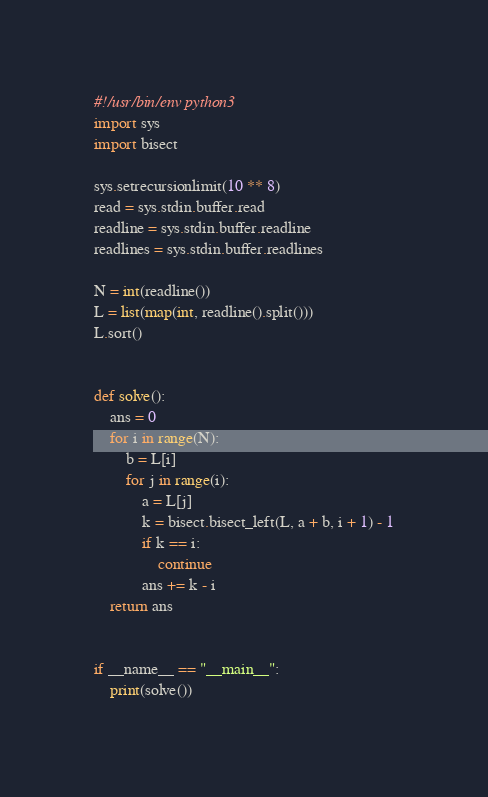Convert code to text. <code><loc_0><loc_0><loc_500><loc_500><_Python_>#!/usr/bin/env python3
import sys
import bisect

sys.setrecursionlimit(10 ** 8)
read = sys.stdin.buffer.read
readline = sys.stdin.buffer.readline
readlines = sys.stdin.buffer.readlines

N = int(readline())
L = list(map(int, readline().split()))
L.sort()


def solve():
    ans = 0
    for i in range(N):
        b = L[i]
        for j in range(i):
            a = L[j]
            k = bisect.bisect_left(L, a + b, i + 1) - 1
            if k == i:
                continue
            ans += k - i
    return ans


if __name__ == "__main__":
    print(solve())
</code> 